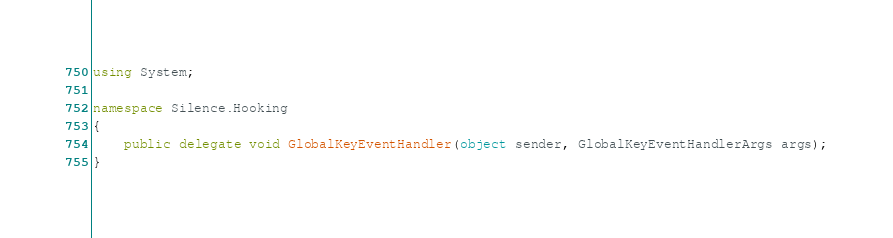Convert code to text. <code><loc_0><loc_0><loc_500><loc_500><_C#_>using System;

namespace Silence.Hooking
{
    public delegate void GlobalKeyEventHandler(object sender, GlobalKeyEventHandlerArgs args);
}
</code> 